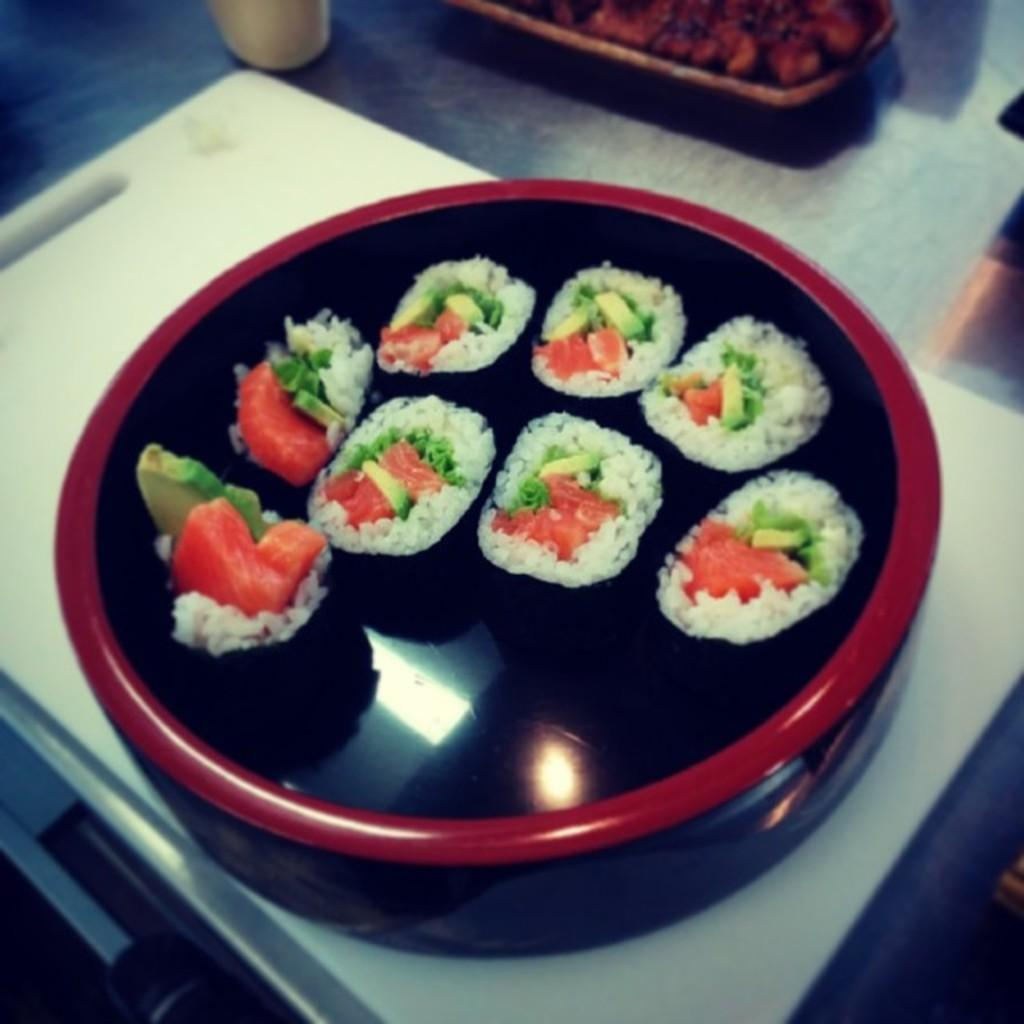What is the main object in the image? There is a box in the image. What is inside the box? The box contains rice balls. Where is the box placed in the image? The box is on a white cutting board. What other items can be seen in the image? There is a cup at the top of the image on the left side, and there is a tray with food on the right side of the image. What type of fish can be seen swimming in the box? There are no fish present in the image; the box contains rice balls. Is there a picture of a quiver hanging on the wall in the image? There is no picture or quiver mentioned in the provided facts, and therefore it cannot be determined if they are present in the image. 